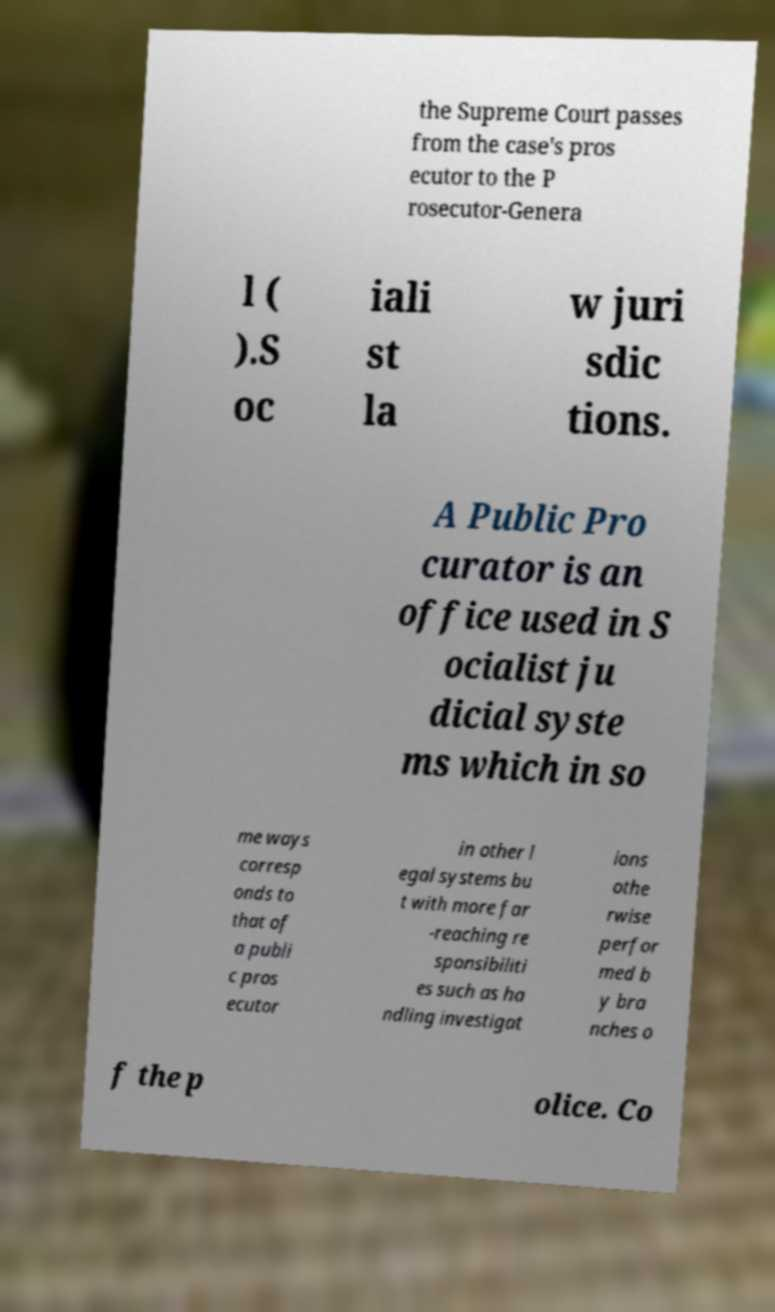What messages or text are displayed in this image? I need them in a readable, typed format. the Supreme Court passes from the case's pros ecutor to the P rosecutor-Genera l ( ).S oc iali st la w juri sdic tions. A Public Pro curator is an office used in S ocialist ju dicial syste ms which in so me ways corresp onds to that of a publi c pros ecutor in other l egal systems bu t with more far -reaching re sponsibiliti es such as ha ndling investigat ions othe rwise perfor med b y bra nches o f the p olice. Co 